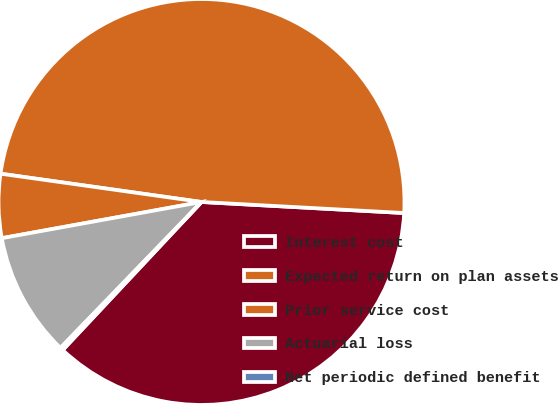Convert chart. <chart><loc_0><loc_0><loc_500><loc_500><pie_chart><fcel>Interest cost<fcel>Expected return on plan assets<fcel>Prior service cost<fcel>Actuarial loss<fcel>Net periodic defined benefit<nl><fcel>36.12%<fcel>48.64%<fcel>5.08%<fcel>9.92%<fcel>0.24%<nl></chart> 